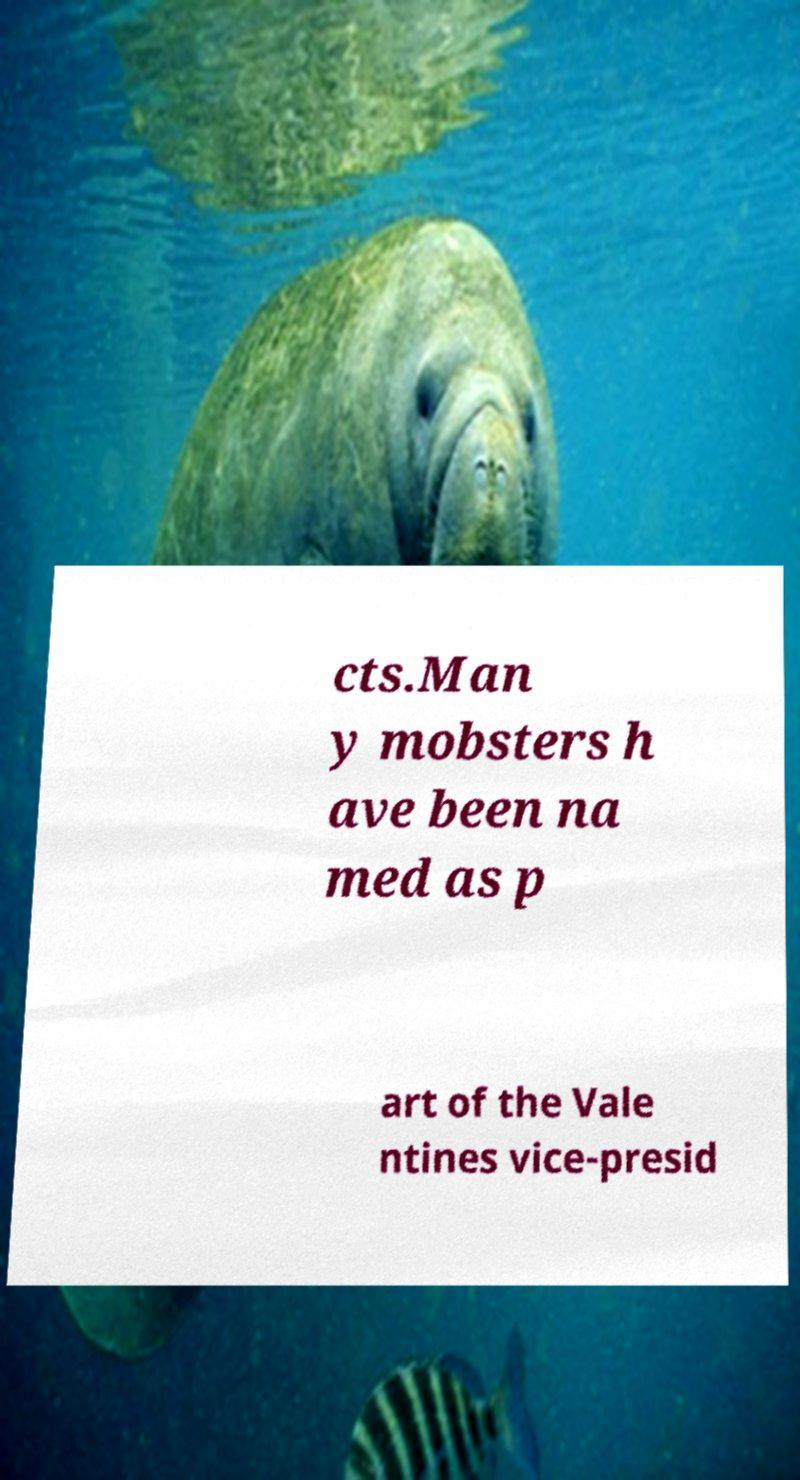Could you assist in decoding the text presented in this image and type it out clearly? cts.Man y mobsters h ave been na med as p art of the Vale ntines vice-presid 